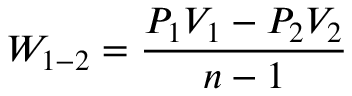<formula> <loc_0><loc_0><loc_500><loc_500>W _ { 1 - 2 } = { \frac { P _ { 1 } V _ { 1 } - P _ { 2 } V _ { 2 } } { n - 1 } }</formula> 